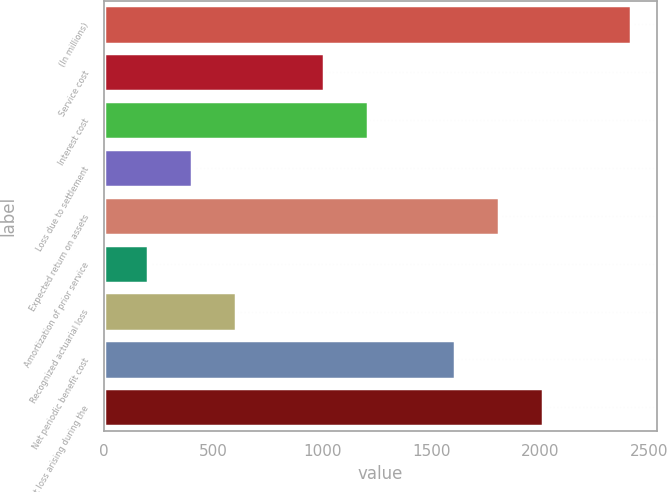<chart> <loc_0><loc_0><loc_500><loc_500><bar_chart><fcel>(In millions)<fcel>Service cost<fcel>Interest cost<fcel>Loss due to settlement<fcel>Expected return on assets<fcel>Amortization of prior service<fcel>Recognized actuarial loss<fcel>Net periodic benefit cost<fcel>Net loss arising during the<nl><fcel>2416.76<fcel>1007.1<fcel>1208.48<fcel>402.96<fcel>1812.62<fcel>201.58<fcel>604.34<fcel>1611.24<fcel>2014<nl></chart> 